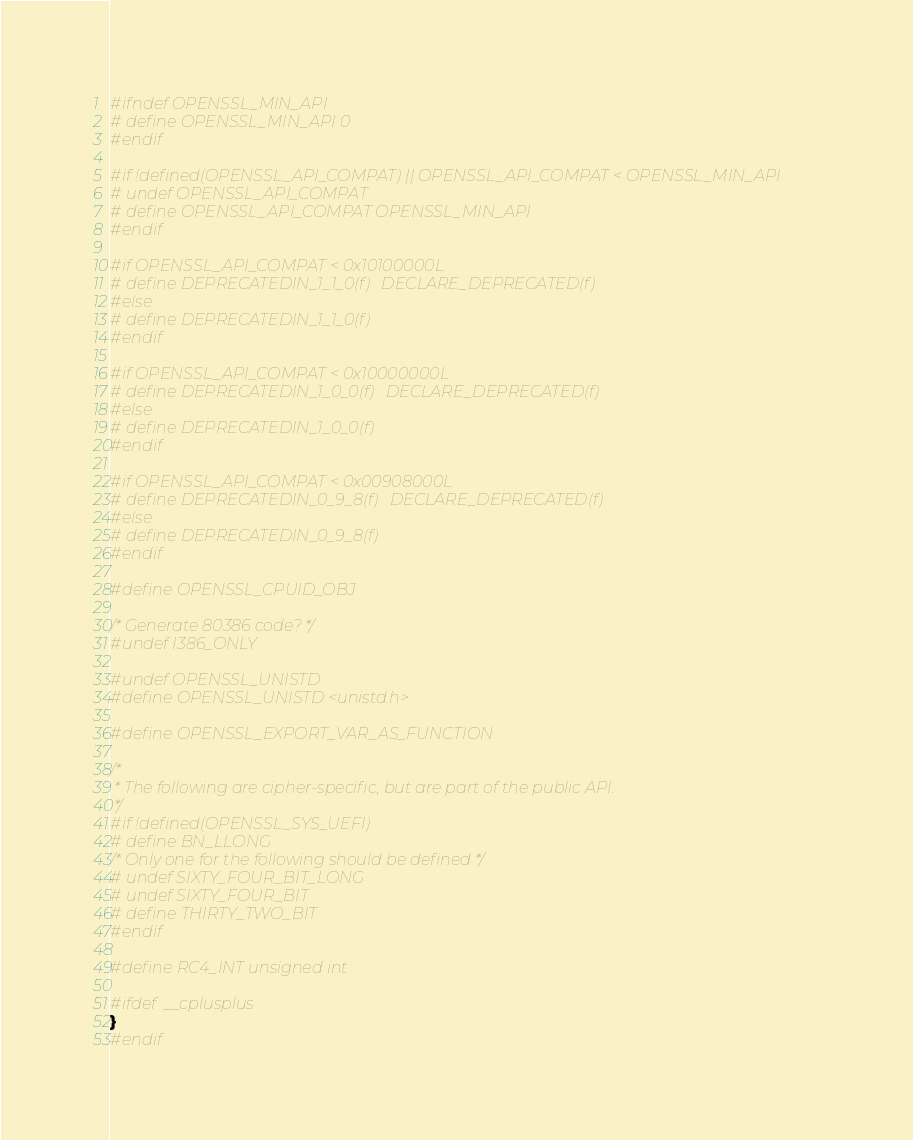<code> <loc_0><loc_0><loc_500><loc_500><_C_>
#ifndef OPENSSL_MIN_API
# define OPENSSL_MIN_API 0
#endif

#if !defined(OPENSSL_API_COMPAT) || OPENSSL_API_COMPAT < OPENSSL_MIN_API
# undef OPENSSL_API_COMPAT
# define OPENSSL_API_COMPAT OPENSSL_MIN_API
#endif

#if OPENSSL_API_COMPAT < 0x10100000L
# define DEPRECATEDIN_1_1_0(f)   DECLARE_DEPRECATED(f)
#else
# define DEPRECATEDIN_1_1_0(f)
#endif

#if OPENSSL_API_COMPAT < 0x10000000L
# define DEPRECATEDIN_1_0_0(f)   DECLARE_DEPRECATED(f)
#else
# define DEPRECATEDIN_1_0_0(f)
#endif

#if OPENSSL_API_COMPAT < 0x00908000L
# define DEPRECATEDIN_0_9_8(f)   DECLARE_DEPRECATED(f)
#else
# define DEPRECATEDIN_0_9_8(f)
#endif

#define OPENSSL_CPUID_OBJ

/* Generate 80386 code? */
#undef I386_ONLY

#undef OPENSSL_UNISTD
#define OPENSSL_UNISTD <unistd.h>

#define OPENSSL_EXPORT_VAR_AS_FUNCTION

/*
 * The following are cipher-specific, but are part of the public API.
 */
#if !defined(OPENSSL_SYS_UEFI)
# define BN_LLONG
/* Only one for the following should be defined */
# undef SIXTY_FOUR_BIT_LONG
# undef SIXTY_FOUR_BIT
# define THIRTY_TWO_BIT
#endif

#define RC4_INT unsigned int

#ifdef  __cplusplus
}
#endif
</code> 